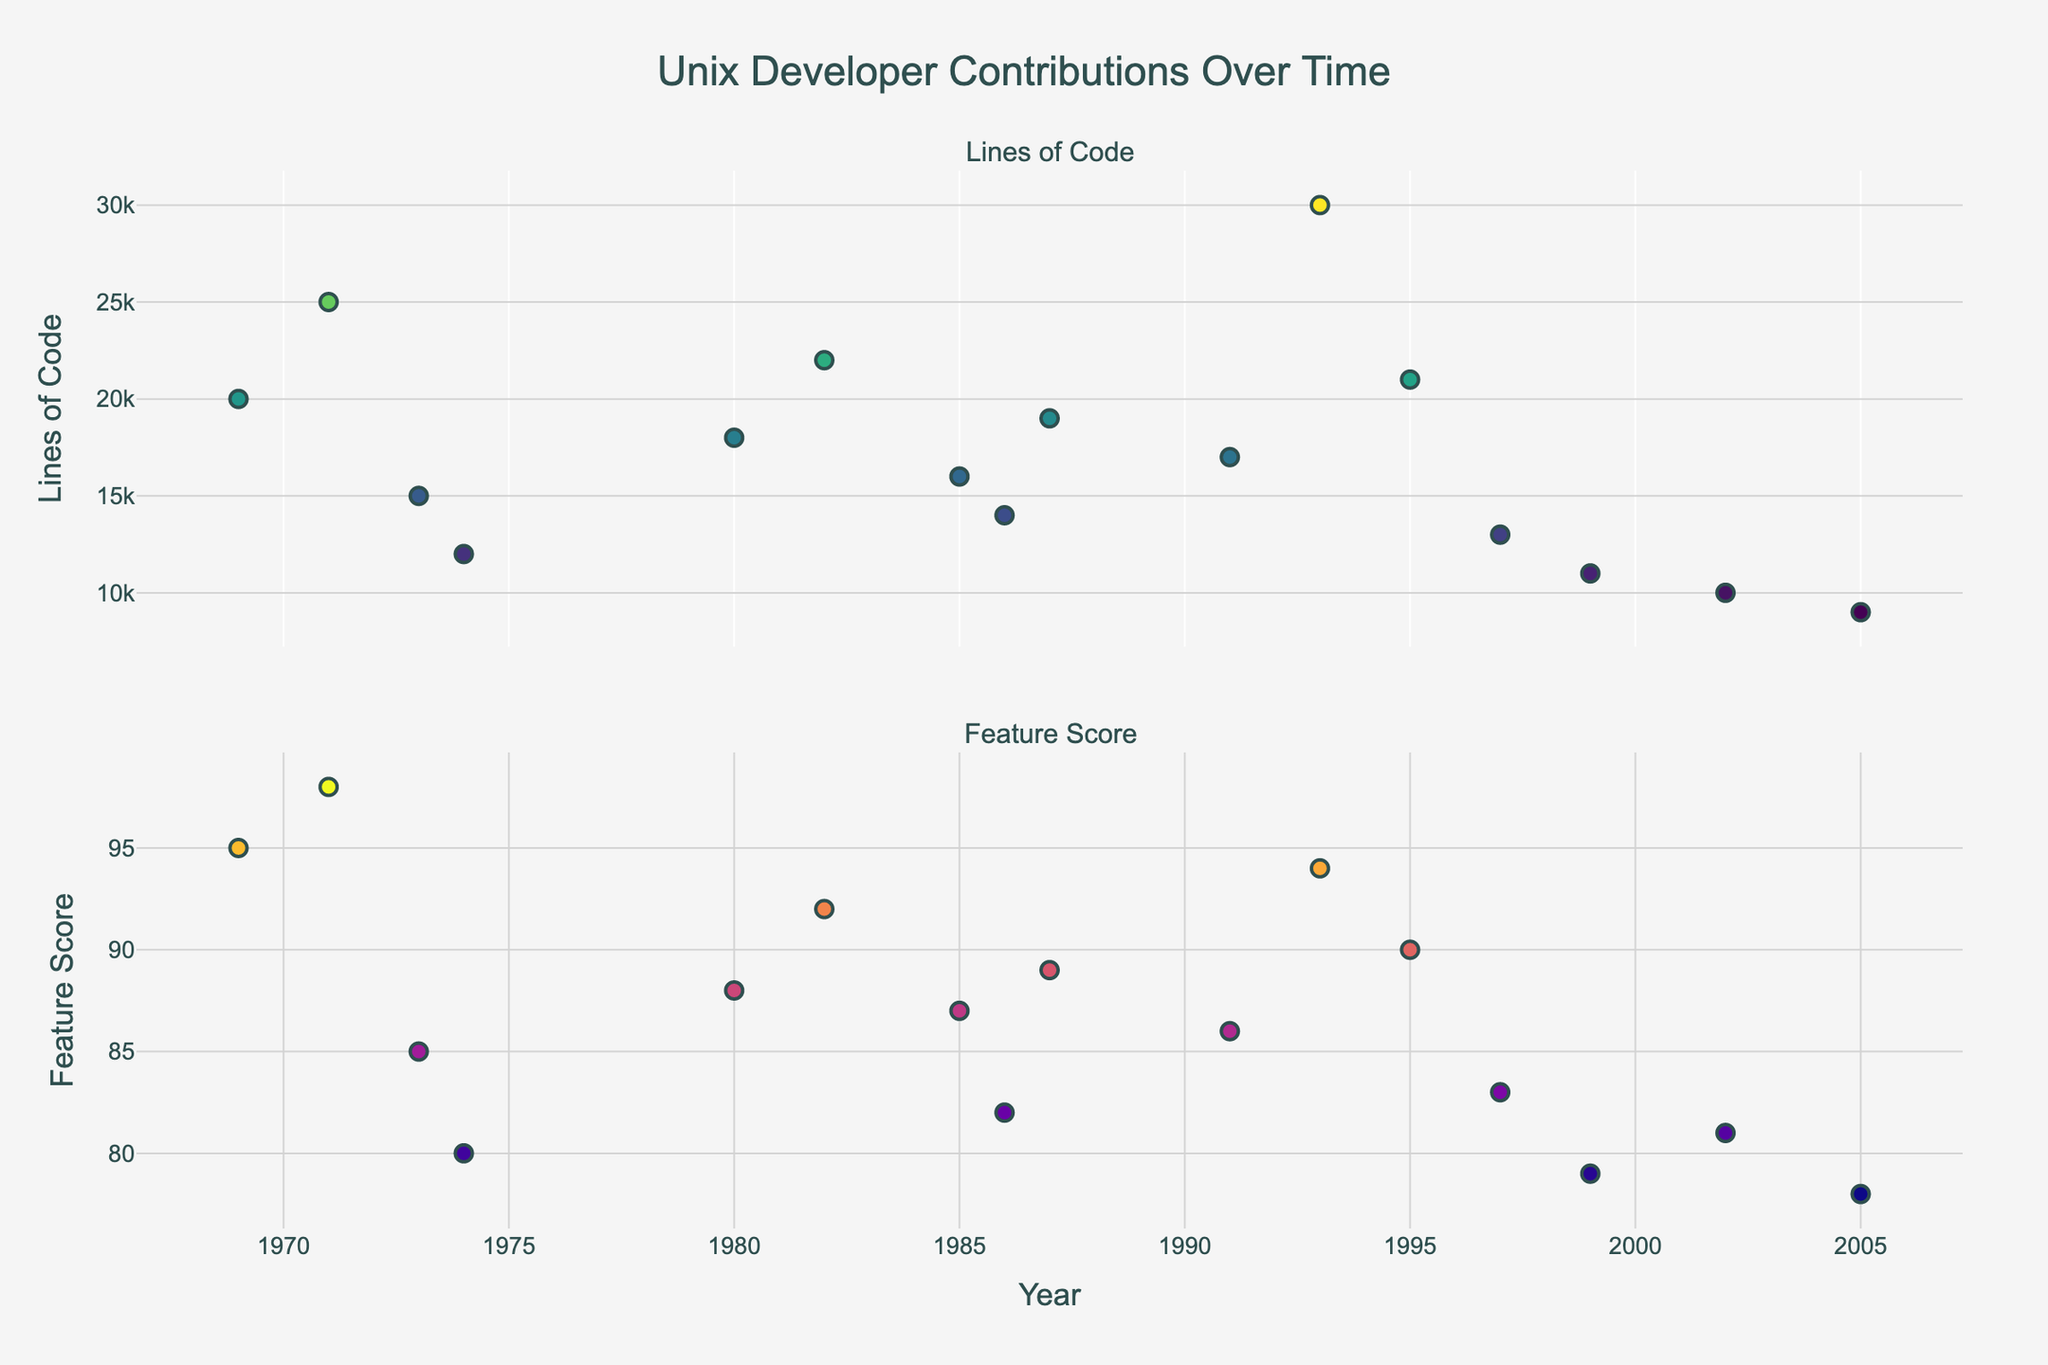What is the title of the plot? The title of the plot is displayed at the top center of the figure. It reads "Unix Developer Contributions Over Time".
Answer: Unix Developer Contributions Over Time How many subplots are present in the figure? Observe the figure layout, it is divided into two subplots stacked vertically.
Answer: Two Which contributor introduced the most lines of code in 1993? Locate the data point on the Lines of Code subplot for the year 1993. Hover over the marker to see the contributor's name.
Answer: Linus Torvalds What is the color scale used for the markers representing Lines of Code? The lines of code are represented using different shades along the 'Viridis' color scale.
Answer: Viridis Who had the highest Feature Score in 1995, and what was the score? Find the data point for the year 1995 in the Feature Score subplot. Hover over the marker to see the contributor and the score.
Answer: Richard Stallman, 90 What is the average number of lines of code contributed by developers from 1969 to 1985? Sum the lines of code for years 1969 (20000), 1971 (25000), 1973 (15000), 1974 (12000), 1980 (18000), 1982 (22000), and 1985 (16000). Then divide by the number of data points (7). Calculation: (20000+25000+15000+12000+18000+22000+16000)/7 = 19857.14
Answer: 19857.14 Who contributed the fewest lines of code and in what year did they make these contributions? Look for the smallest data point in the Lines of Code subplot. Hover over the marker to identify the contributor and the year.
Answer: Ken Arnold, 2005 Between 1986 and 1997, which contributor had the lowest feature score and what was the score? Consider data points from 1986 to 1997 in the Feature Score subplot. Identify the lowest score and hover over the marker to see the corresponding contributor and year.
Answer: Kirk McKusick, 83 Which year had the highest concentration of high feature scores (greater than 90)? Scan through the Feature Score subplot and count the number of scores above 90 for each year. The year with the highest count is the answer. Calculation: 1969 (1), 1971 (1), 1993 (1), 1995 (1). Thus, multiple years have one high feature score each.
Answer: 1969, 1971, 1993, and 1995 